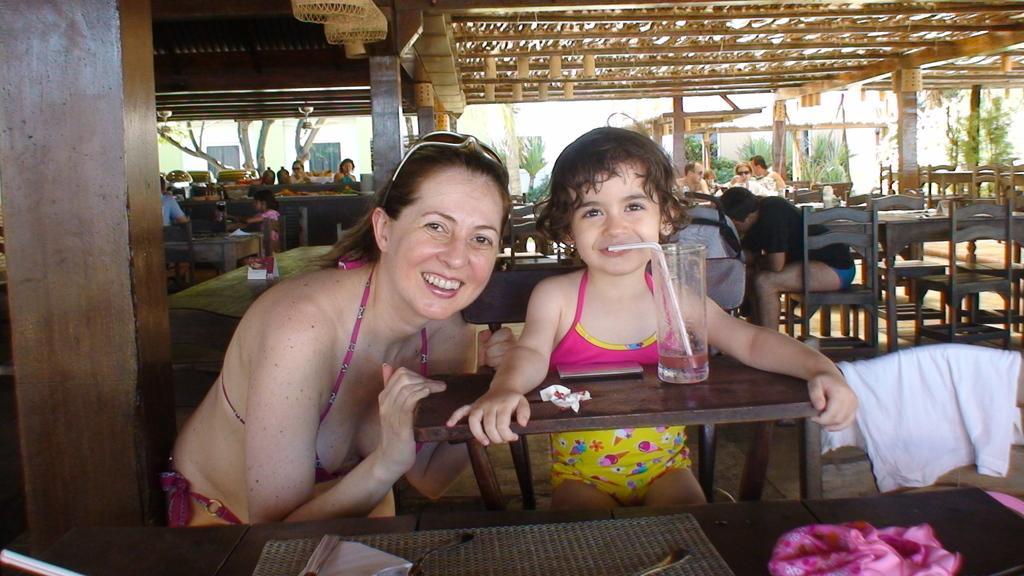Can you describe this image briefly? This picture shows a woman and a girl seated on the chair and we see a glass with straw and we see few people seated on the back 